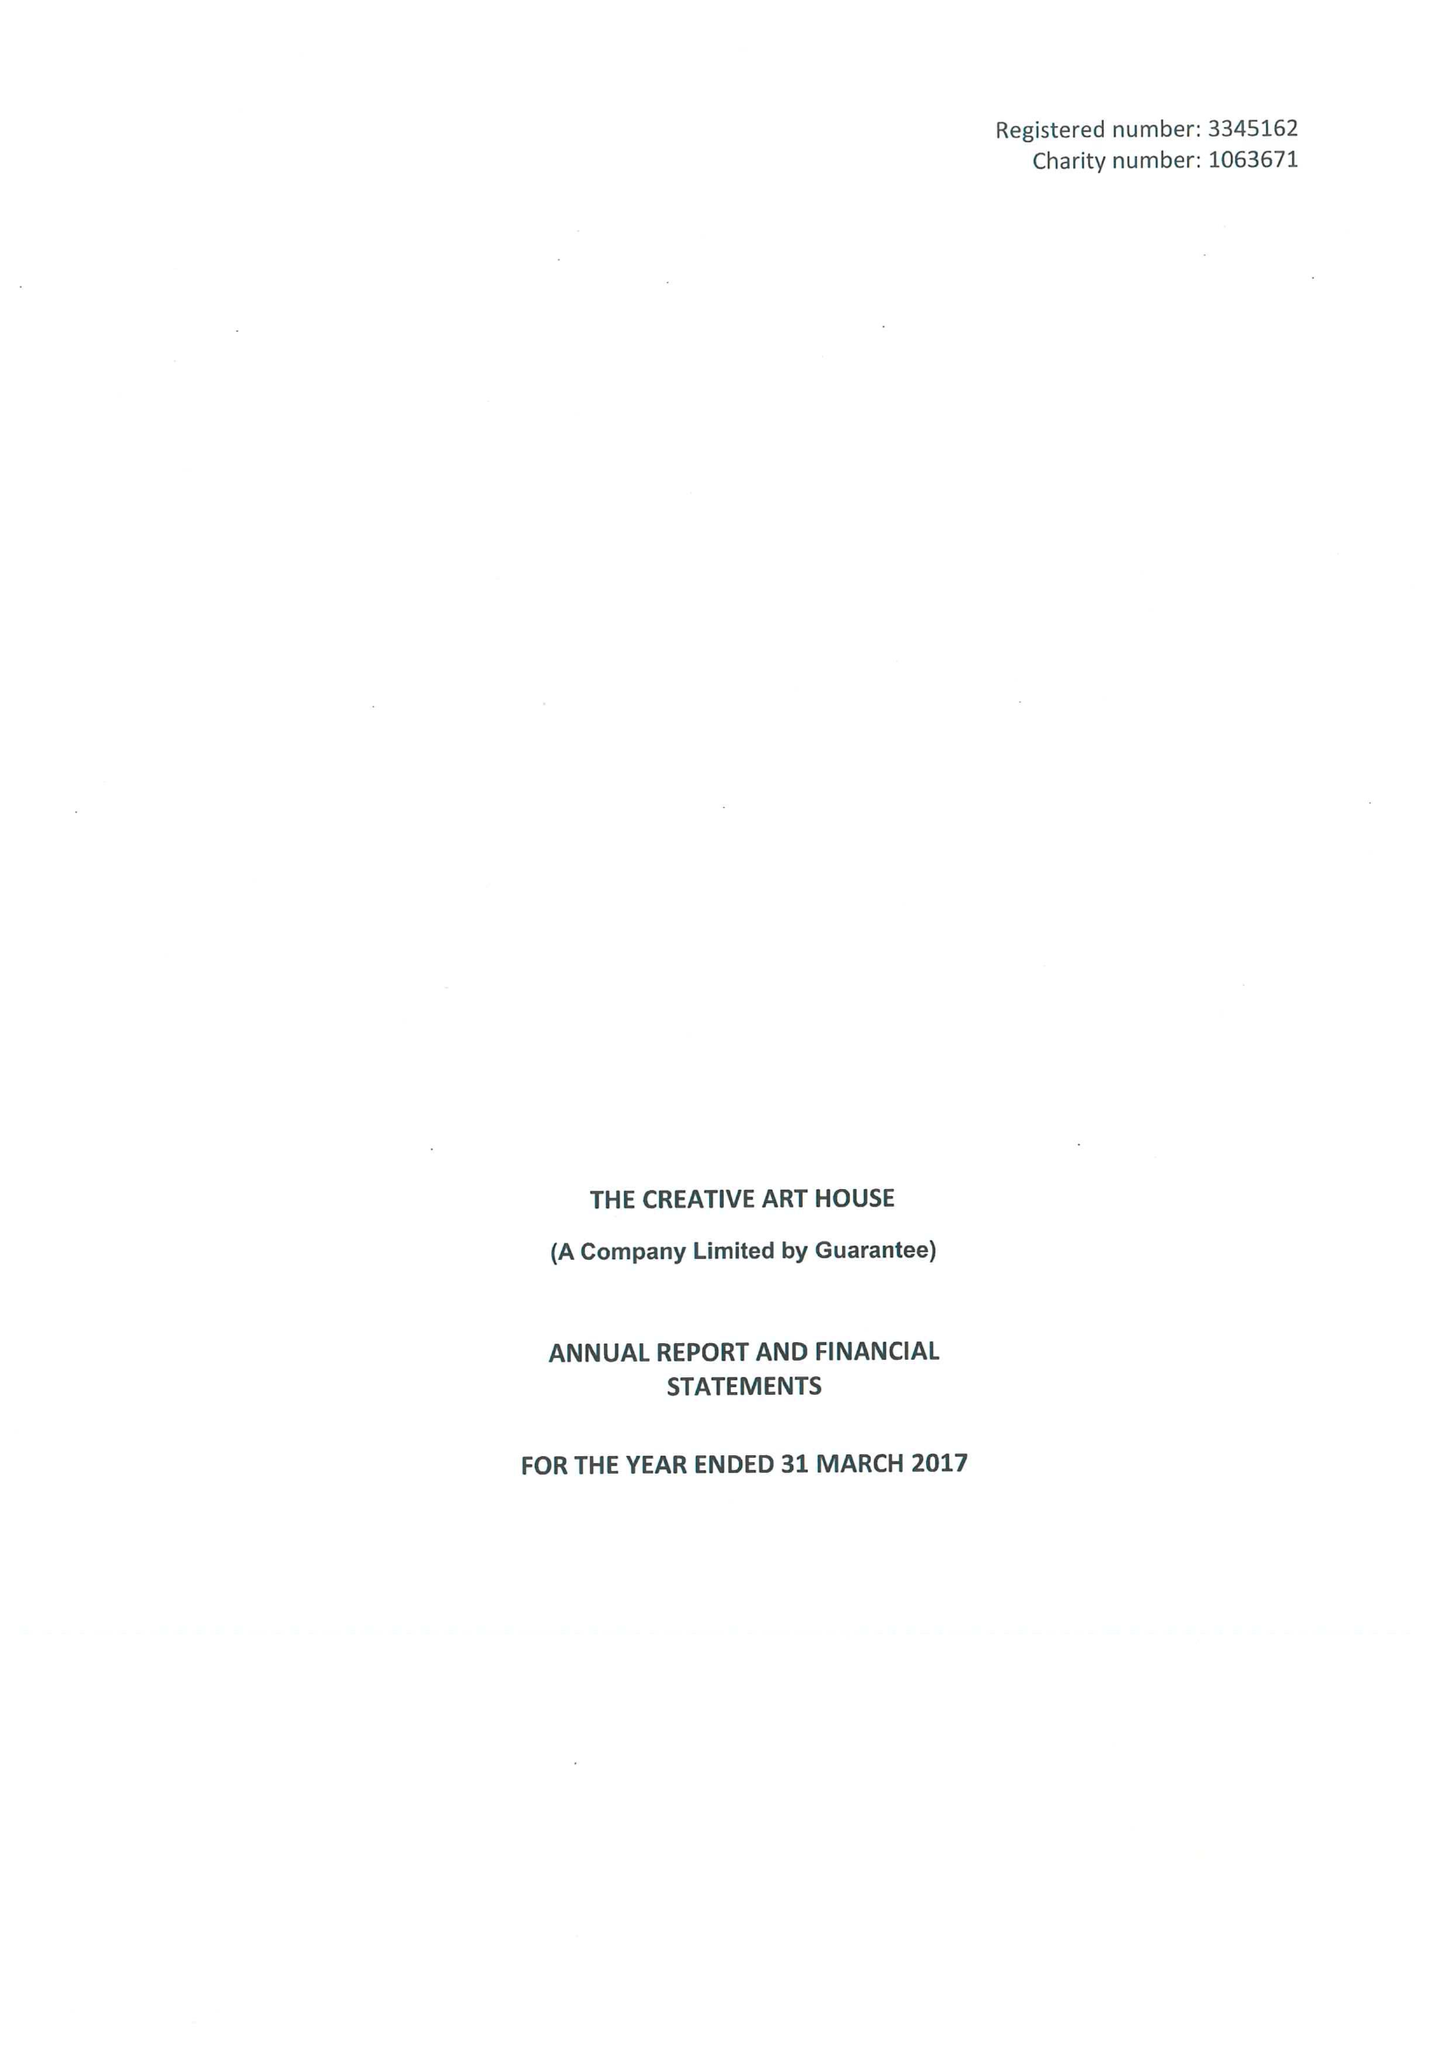What is the value for the income_annually_in_british_pounds?
Answer the question using a single word or phrase. 283737.00 